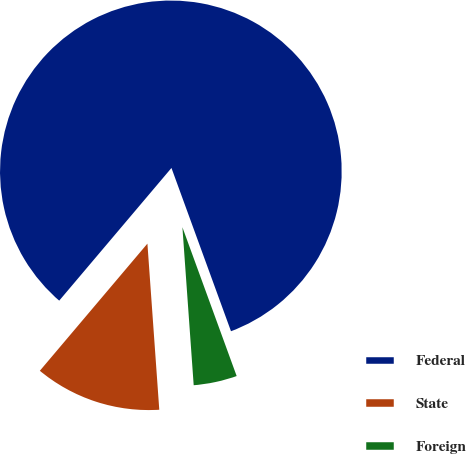Convert chart. <chart><loc_0><loc_0><loc_500><loc_500><pie_chart><fcel>Federal<fcel>State<fcel>Foreign<nl><fcel>83.26%<fcel>12.31%<fcel>4.43%<nl></chart> 